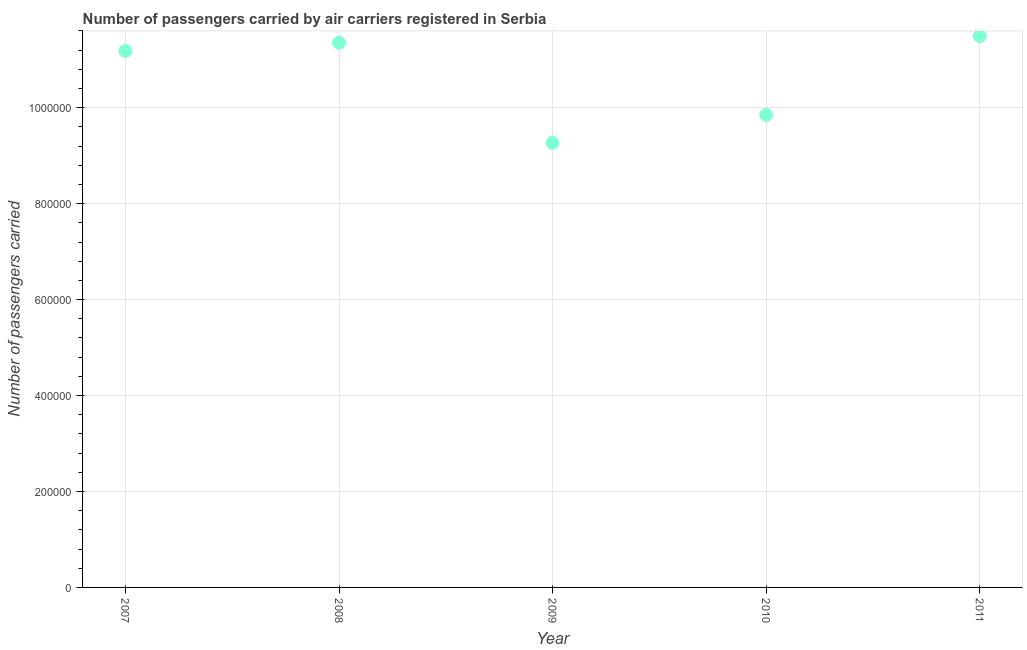What is the number of passengers carried in 2007?
Your response must be concise. 1.12e+06. Across all years, what is the maximum number of passengers carried?
Make the answer very short. 1.15e+06. Across all years, what is the minimum number of passengers carried?
Make the answer very short. 9.27e+05. In which year was the number of passengers carried maximum?
Your response must be concise. 2011. What is the sum of the number of passengers carried?
Make the answer very short. 5.31e+06. What is the difference between the number of passengers carried in 2008 and 2010?
Your answer should be very brief. 1.50e+05. What is the average number of passengers carried per year?
Your response must be concise. 1.06e+06. What is the median number of passengers carried?
Your response must be concise. 1.12e+06. Do a majority of the years between 2010 and 2008 (inclusive) have number of passengers carried greater than 840000 ?
Your answer should be compact. No. What is the ratio of the number of passengers carried in 2010 to that in 2011?
Give a very brief answer. 0.86. What is the difference between the highest and the second highest number of passengers carried?
Your answer should be very brief. 1.38e+04. What is the difference between the highest and the lowest number of passengers carried?
Make the answer very short. 2.22e+05. In how many years, is the number of passengers carried greater than the average number of passengers carried taken over all years?
Ensure brevity in your answer.  3. How many years are there in the graph?
Provide a succinct answer. 5. What is the difference between two consecutive major ticks on the Y-axis?
Provide a succinct answer. 2.00e+05. Are the values on the major ticks of Y-axis written in scientific E-notation?
Keep it short and to the point. No. Does the graph contain grids?
Offer a very short reply. Yes. What is the title of the graph?
Give a very brief answer. Number of passengers carried by air carriers registered in Serbia. What is the label or title of the Y-axis?
Offer a very short reply. Number of passengers carried. What is the Number of passengers carried in 2007?
Your response must be concise. 1.12e+06. What is the Number of passengers carried in 2008?
Your response must be concise. 1.14e+06. What is the Number of passengers carried in 2009?
Keep it short and to the point. 9.27e+05. What is the Number of passengers carried in 2010?
Your answer should be compact. 9.85e+05. What is the Number of passengers carried in 2011?
Offer a very short reply. 1.15e+06. What is the difference between the Number of passengers carried in 2007 and 2008?
Your response must be concise. -1.69e+04. What is the difference between the Number of passengers carried in 2007 and 2009?
Your answer should be very brief. 1.92e+05. What is the difference between the Number of passengers carried in 2007 and 2010?
Offer a terse response. 1.33e+05. What is the difference between the Number of passengers carried in 2007 and 2011?
Make the answer very short. -3.07e+04. What is the difference between the Number of passengers carried in 2008 and 2009?
Provide a succinct answer. 2.09e+05. What is the difference between the Number of passengers carried in 2008 and 2010?
Provide a short and direct response. 1.50e+05. What is the difference between the Number of passengers carried in 2008 and 2011?
Offer a terse response. -1.38e+04. What is the difference between the Number of passengers carried in 2009 and 2010?
Your response must be concise. -5.85e+04. What is the difference between the Number of passengers carried in 2009 and 2011?
Offer a very short reply. -2.22e+05. What is the difference between the Number of passengers carried in 2010 and 2011?
Provide a succinct answer. -1.64e+05. What is the ratio of the Number of passengers carried in 2007 to that in 2008?
Offer a very short reply. 0.98. What is the ratio of the Number of passengers carried in 2007 to that in 2009?
Make the answer very short. 1.21. What is the ratio of the Number of passengers carried in 2007 to that in 2010?
Provide a short and direct response. 1.14. What is the ratio of the Number of passengers carried in 2007 to that in 2011?
Offer a very short reply. 0.97. What is the ratio of the Number of passengers carried in 2008 to that in 2009?
Provide a short and direct response. 1.23. What is the ratio of the Number of passengers carried in 2008 to that in 2010?
Give a very brief answer. 1.15. What is the ratio of the Number of passengers carried in 2009 to that in 2010?
Make the answer very short. 0.94. What is the ratio of the Number of passengers carried in 2009 to that in 2011?
Keep it short and to the point. 0.81. What is the ratio of the Number of passengers carried in 2010 to that in 2011?
Provide a succinct answer. 0.86. 